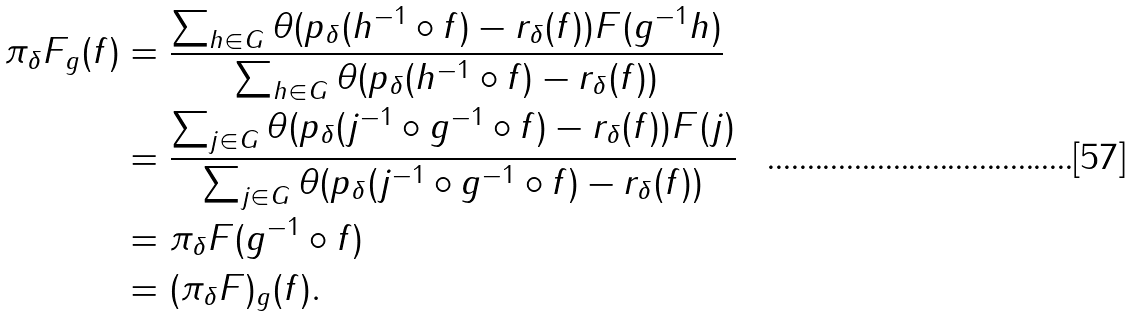<formula> <loc_0><loc_0><loc_500><loc_500>\pi _ { \delta } F _ { g } ( f ) & = \frac { \sum _ { h \in G } \theta ( p _ { \delta } ( h ^ { - 1 } \circ f ) - r _ { \delta } ( f ) ) F ( g ^ { - 1 } h ) } { \sum _ { h \in G } \theta ( p _ { \delta } ( h ^ { - 1 } \circ f ) - r _ { \delta } ( f ) ) } \\ & = \frac { \sum _ { j \in G } \theta ( p _ { \delta } ( j ^ { - 1 } \circ g ^ { - 1 } \circ f ) - r _ { \delta } ( f ) ) F ( j ) } { \sum _ { j \in G } \theta ( p _ { \delta } ( j ^ { - 1 } \circ g ^ { - 1 } \circ f ) - r _ { \delta } ( f ) ) } \\ & = \pi _ { \delta } F ( g ^ { - 1 } \circ f ) \\ & = ( \pi _ { \delta } F ) _ { g } ( f ) .</formula> 